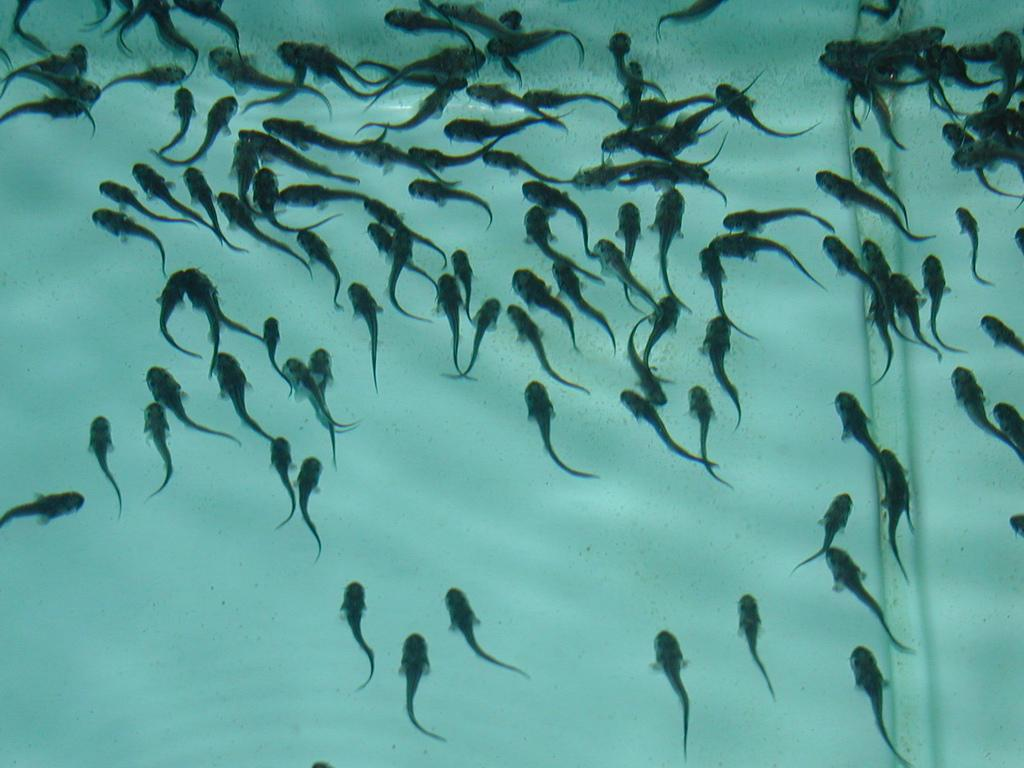What type of animals can be seen in the image? There are fishes visible in the water. What is the color of the background in the image? The background of the image is white in color. Where is the duck located in the image? There is no duck present in the image. What type of book can be seen on the table in the image? There is no table or book present in the image. 